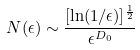<formula> <loc_0><loc_0><loc_500><loc_500>N ( \epsilon ) \sim \frac { [ \ln ( 1 / \epsilon ) ] ^ { \frac { 1 } { 2 } } } { \epsilon ^ { D _ { 0 } } }</formula> 